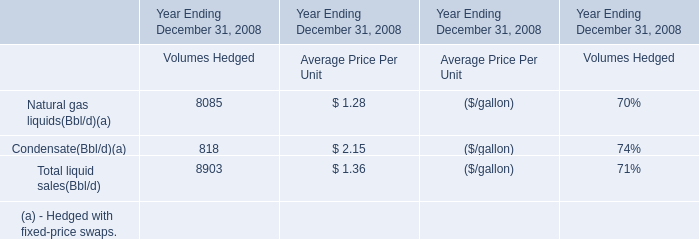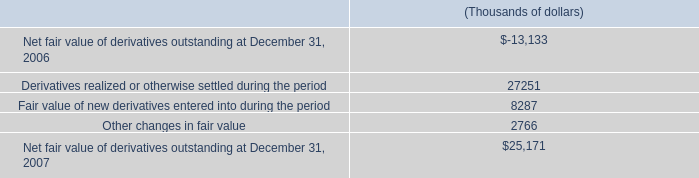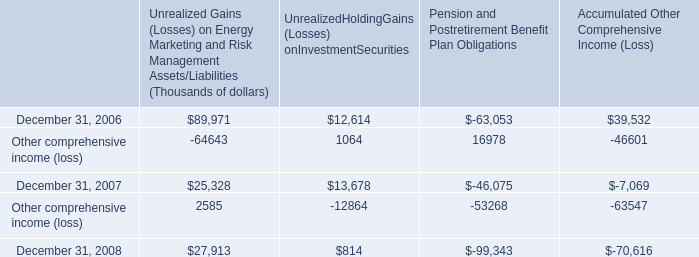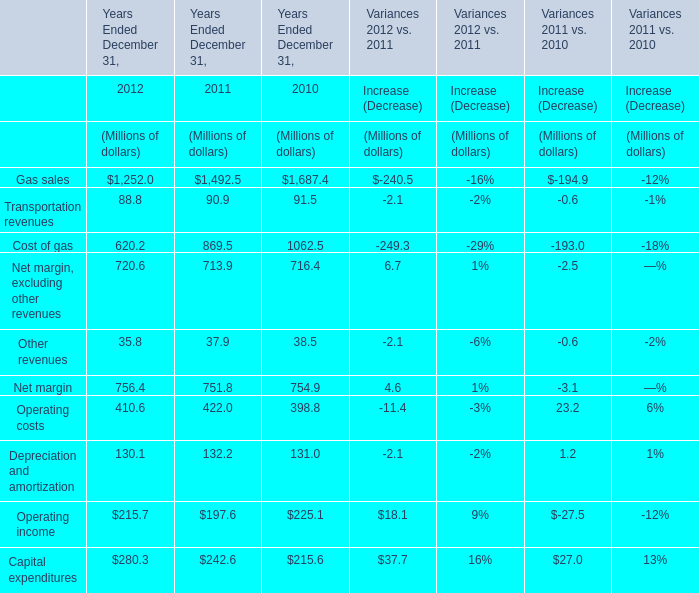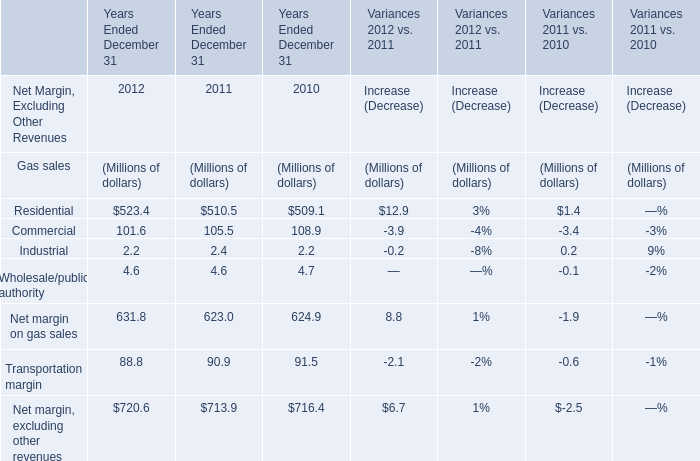What is the growing rate of Industrial in the years with the least Commercial? (in %) 
Computations: ((2.2 - 2.4) / 2.4)
Answer: -0.08333. 